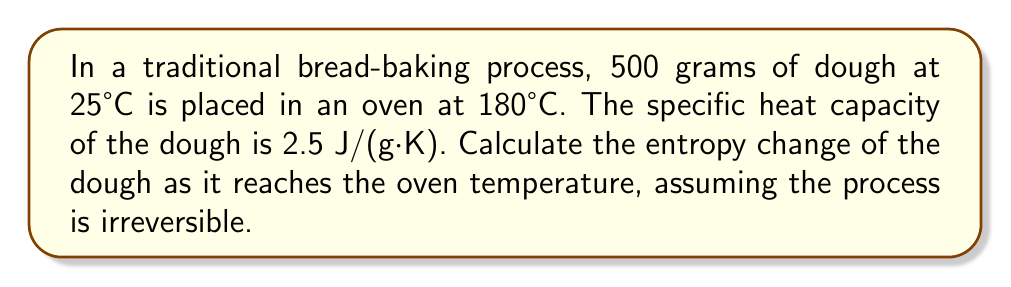Provide a solution to this math problem. To calculate the entropy change in this irreversible process, we'll use the concept of entropy change for an irreversible process, which is always greater than or equal to the entropy change for a reversible process.

Step 1: Calculate the entropy change as if it were a reversible process.
The formula for entropy change in a reversible process is:
$$\Delta S = mc \ln\left(\frac{T_f}{T_i}\right)$$
Where:
$m$ = mass of the dough
$c$ = specific heat capacity of the dough
$T_f$ = final temperature
$T_i$ = initial temperature

Step 2: Convert temperatures to Kelvin.
$T_i = 25°C + 273.15 = 298.15 K$
$T_f = 180°C + 273.15 = 453.15 K$

Step 3: Substitute the values into the equation.
$$\Delta S = (500 \text{ g})(2.5 \text{ J/(g·K)}) \ln\left(\frac{453.15 \text{ K}}{298.15 \text{ K}}\right)$$

Step 4: Calculate the result.
$$\Delta S = 1250 \text{ J/K} \cdot \ln(1.5199)$$
$$\Delta S = 1250 \text{ J/K} \cdot 0.4187$$
$$\Delta S = 523.38 \text{ J/K}$$

Step 5: Since the actual process is irreversible, the entropy change will be greater than this calculated value. We can express this as:
$$\Delta S_{\text{irreversible}} > 523.38 \text{ J/K}$$
Answer: $\Delta S > 523.38 \text{ J/K}$ 